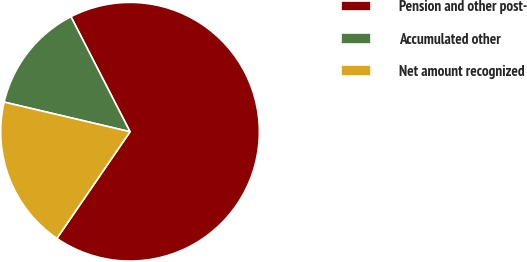Convert chart. <chart><loc_0><loc_0><loc_500><loc_500><pie_chart><fcel>Pension and other post-<fcel>Accumulated other<fcel>Net amount recognized<nl><fcel>67.12%<fcel>13.77%<fcel>19.11%<nl></chart> 